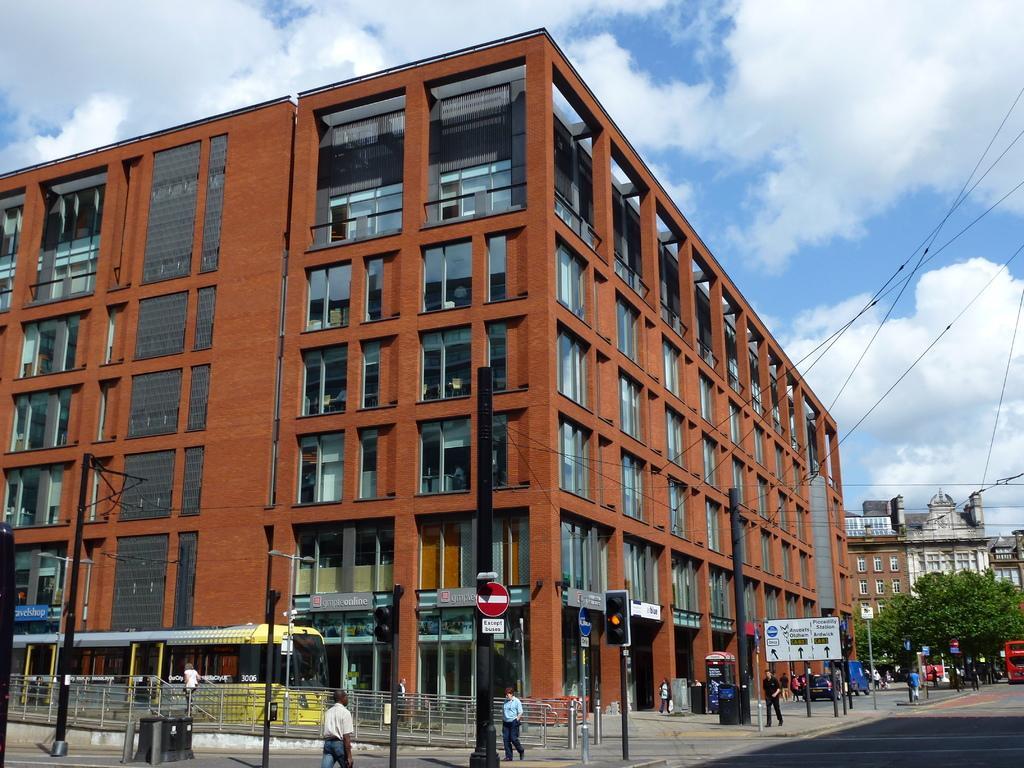In one or two sentences, can you explain what this image depicts? In this image in the front there are poles and in the center there are persons walking and there are poles. In the background there are buildings, trees and there is a bus which is red in colour moving on the road and the sky is cloudy and there are wires. 